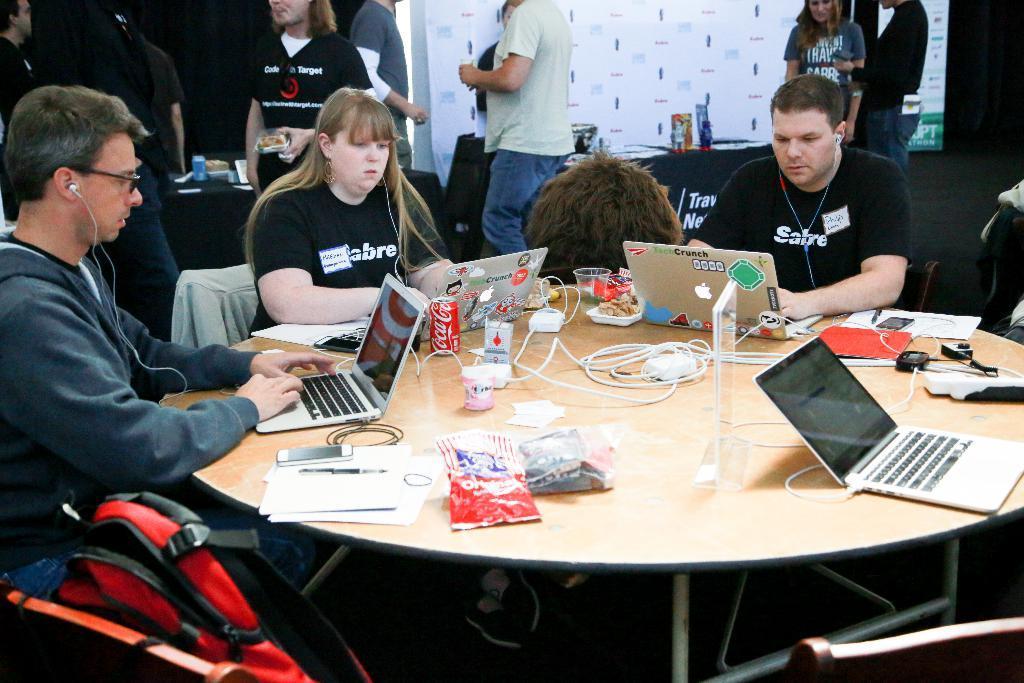Please provide a concise description of this image. In this image i can see 3 persons sitting in front of a table. On the table i can see laptops, wires, covers, cellphone, papers and a pen. On the background i can see few people standing, a table and a banner. 